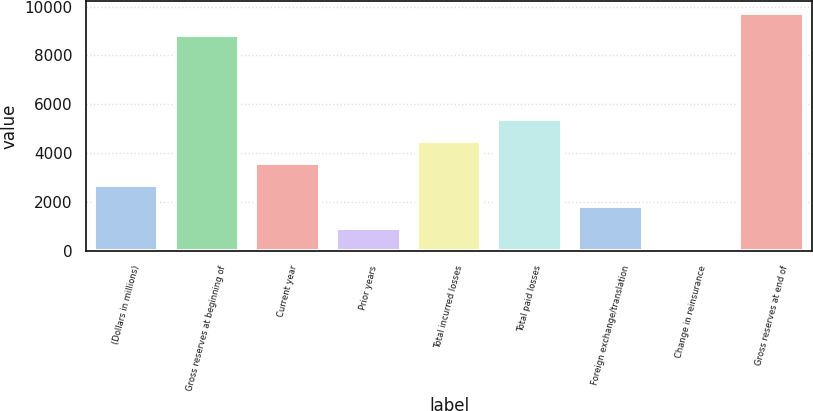Convert chart. <chart><loc_0><loc_0><loc_500><loc_500><bar_chart><fcel>(Dollars in millions)<fcel>Gross reserves at beginning of<fcel>Current year<fcel>Prior years<fcel>Total incurred losses<fcel>Total paid losses<fcel>Foreign exchange/translation<fcel>Change in reinsurance<fcel>Gross reserves at end of<nl><fcel>2715.81<fcel>8840.7<fcel>3604.68<fcel>938.07<fcel>4493.55<fcel>5382.42<fcel>1826.94<fcel>49.2<fcel>9729.57<nl></chart> 